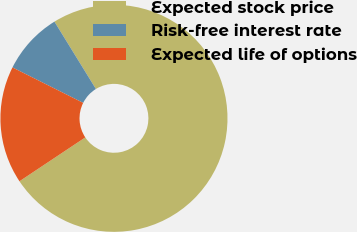Convert chart to OTSL. <chart><loc_0><loc_0><loc_500><loc_500><pie_chart><fcel>Expected stock price<fcel>Risk-free interest rate<fcel>Expected life of options<nl><fcel>74.43%<fcel>8.82%<fcel>16.75%<nl></chart> 